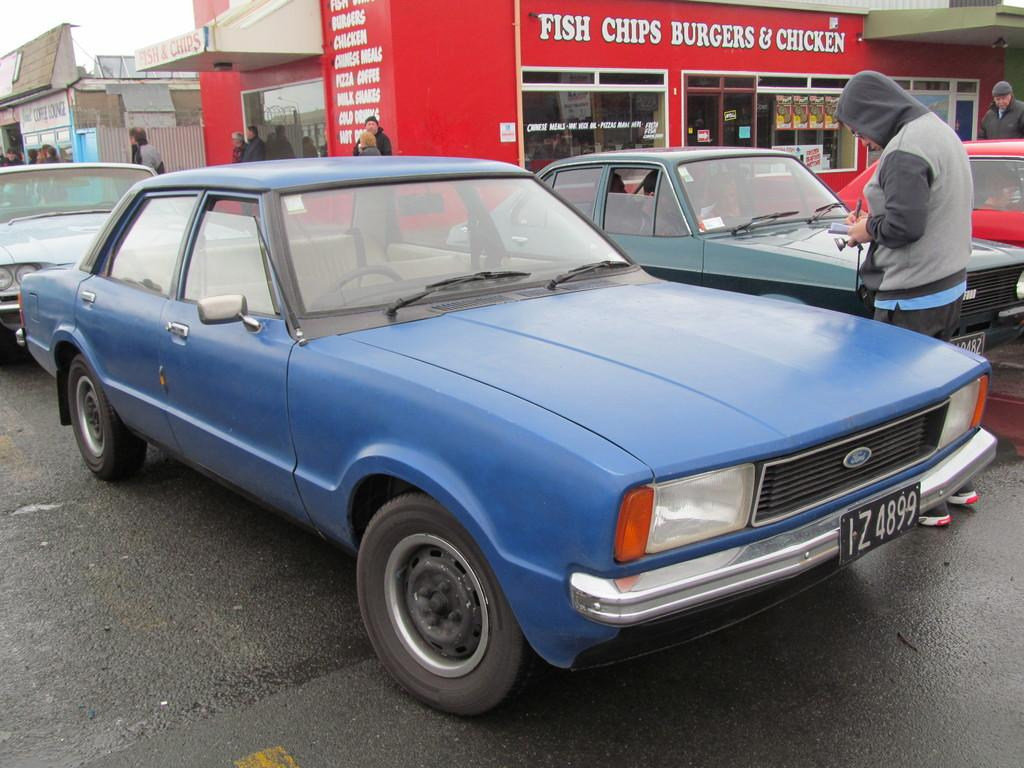<image>
Summarize the visual content of the image. Several cars are parked in front of a restaurant that serves fish, chips, burgers and chicken. 